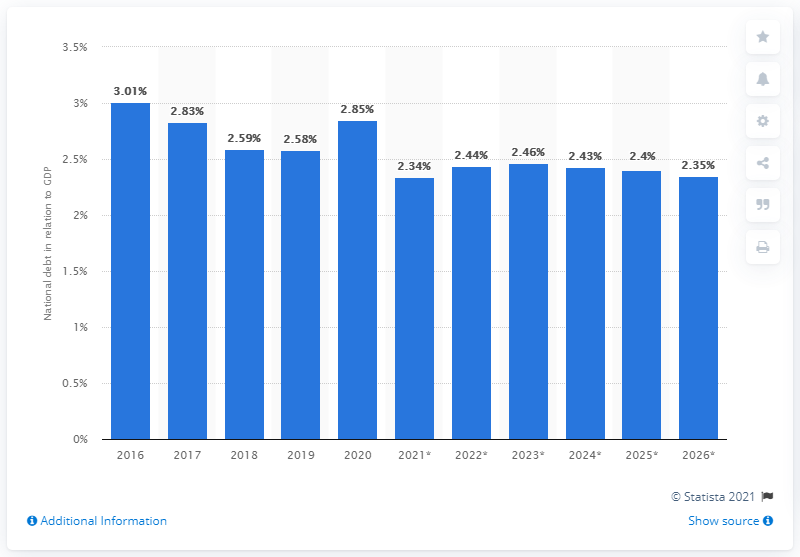Give some essential details in this illustration. In 2020, the national debt of Brunei Darussalam was 2.85. 